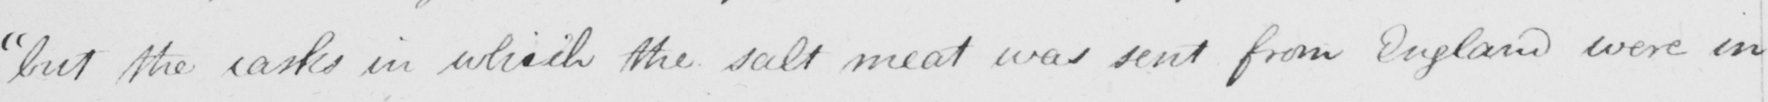What does this handwritten line say? but the casks in which the salt meat was sent from England were in 